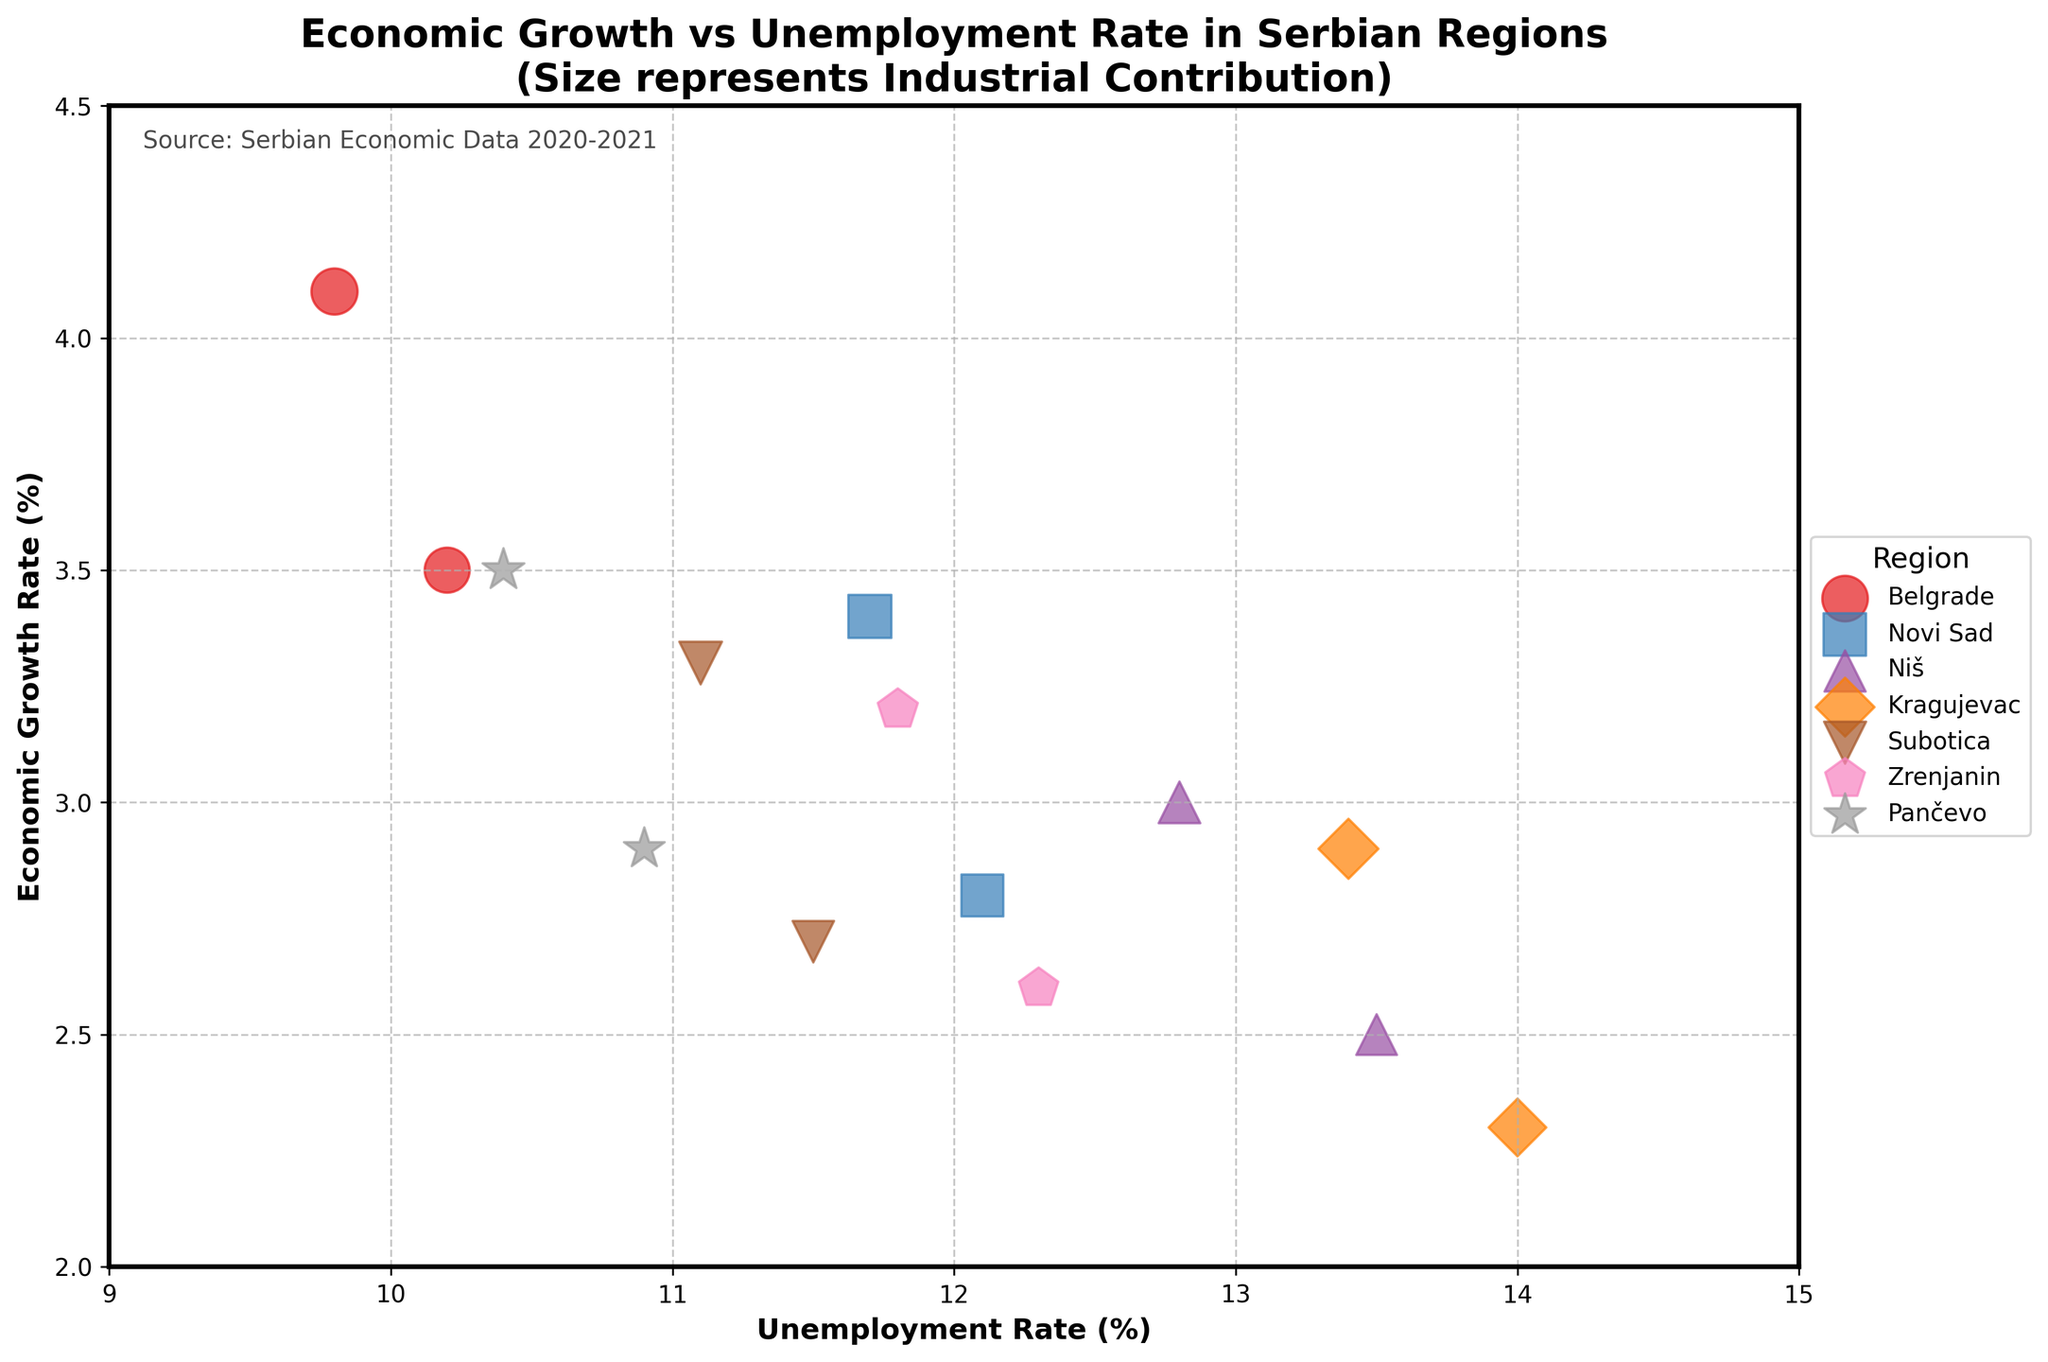How many regions are represented in the figure? The legend shows unique markers and colors representing different regions. Counting these, we find there are 7 regions.
Answer: 7 What is the title of the figure? The title of the figure is displayed at the top center. It reads "Economic Growth vs Unemployment Rate in Serbian Regions\n(Size represents Industrial Contribution)".
Answer: Economic Growth vs Unemployment Rate in Serbian Regions\n(Size represents Industrial Contribution) Which region has the lowest unemployment rate in 2021? Look for the lowest point on the x-axis for the year 2021, then check the legend right to match the marker and color. Pančevo has the lowest unemployment rate in 2021 with an unemployment rate of 10.4%.
Answer: Pančevo What is the Industrial Contribution for Novi Sad in 2021? Locate the scatter point for Novi Sad in 2021 and observe the size of the marker, which indicates the Industrial Contribution. From the data, Novi Sad's Industrial Contribution in 2021 is 32.4.
Answer: 32.4 Which region experienced the highest economic growth rate in 2021? Look for the highest point on the y-axis for the year 2021, then check the legend for the matching marker and color. Belgrade has the highest economic growth rate in 2021, with a growth rate of 4.1%.
Answer: Belgrade Compare the unemployment rates between Belgrade and Novi Sad in 2020. Which one is lower? Identify the points for Belgrade and Novi Sad in 2020, and compare their positions on the x-axis. Belgrade's unemployment rate is 10.2% while Novi Sad's is 12.1%. Belgrade has the lower unemployment rate.
Answer: Belgrade What is the economic growth rate of Niš in 2020 and 2021? Find the points for Niš in both years and note their y-axis positions. Niš's economic growth rate in 2020 is 2.5% and in 2021 is 3.0%.
Answer: 2.5% in 2020 and 3.0% in 2021 By how much did the Industrial Contribution increase for Kragujevac from 2020 to 2021? Compare the marker sizes of Kragujevac in 2020 and 2021. From the data, Kragujevac's Industrial Contribution increased from 29.1 in 2020 to 31.5 in 2021. The increase is 31.5 - 29.1 = 2.4.
Answer: 2.4 Which region has the smallest change in economic growth rate between 2020 and 2021? Calculate the differences in economic growth rates for each region and identify the smallest change. The differences are: Belgrade 0.6, Novi Sad 0.6, Niš 0.5, Kragujevac 0.6, Subotica 0.6, Zrenjanin 0.6, Pančevo 0.6. Niš has the smallest change, with a difference of 0.5.
Answer: Niš 